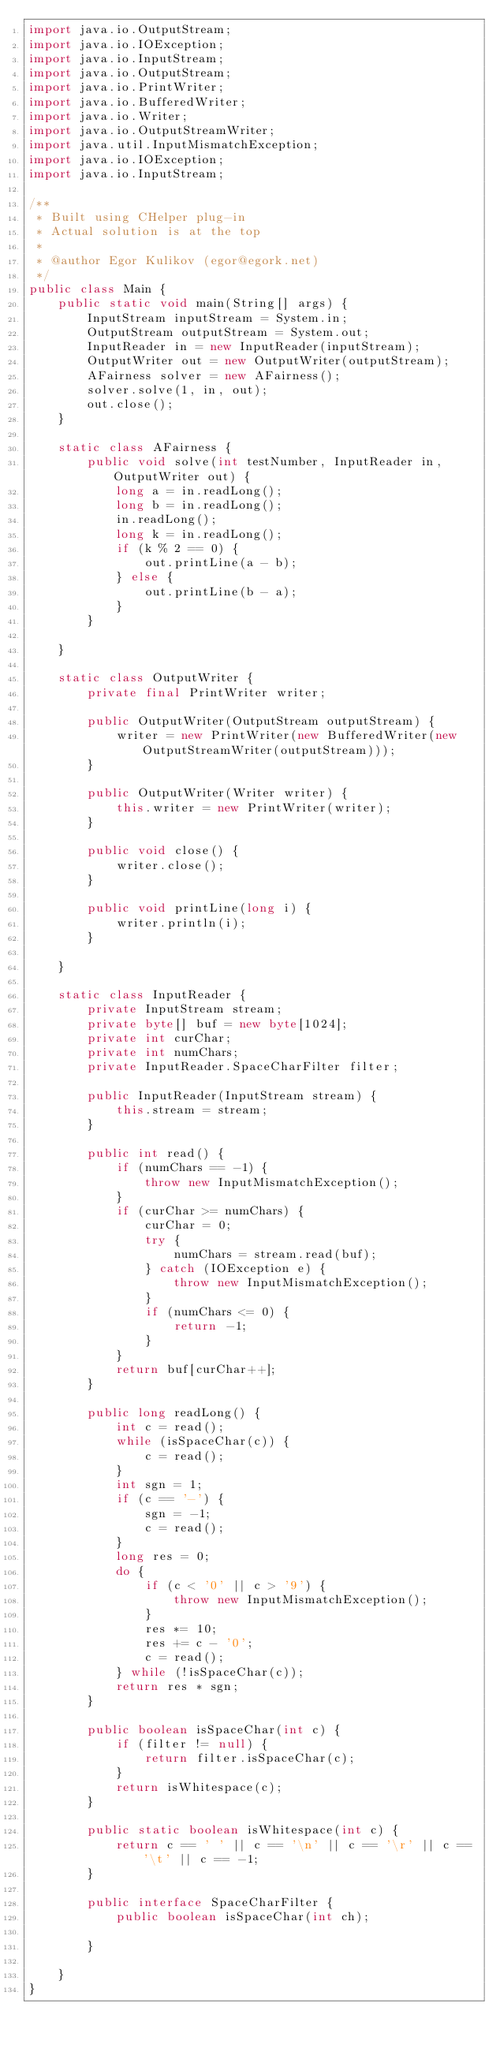Convert code to text. <code><loc_0><loc_0><loc_500><loc_500><_Java_>import java.io.OutputStream;
import java.io.IOException;
import java.io.InputStream;
import java.io.OutputStream;
import java.io.PrintWriter;
import java.io.BufferedWriter;
import java.io.Writer;
import java.io.OutputStreamWriter;
import java.util.InputMismatchException;
import java.io.IOException;
import java.io.InputStream;

/**
 * Built using CHelper plug-in
 * Actual solution is at the top
 *
 * @author Egor Kulikov (egor@egork.net)
 */
public class Main {
    public static void main(String[] args) {
        InputStream inputStream = System.in;
        OutputStream outputStream = System.out;
        InputReader in = new InputReader(inputStream);
        OutputWriter out = new OutputWriter(outputStream);
        AFairness solver = new AFairness();
        solver.solve(1, in, out);
        out.close();
    }

    static class AFairness {
        public void solve(int testNumber, InputReader in, OutputWriter out) {
            long a = in.readLong();
            long b = in.readLong();
            in.readLong();
            long k = in.readLong();
            if (k % 2 == 0) {
                out.printLine(a - b);
            } else {
                out.printLine(b - a);
            }
        }

    }

    static class OutputWriter {
        private final PrintWriter writer;

        public OutputWriter(OutputStream outputStream) {
            writer = new PrintWriter(new BufferedWriter(new OutputStreamWriter(outputStream)));
        }

        public OutputWriter(Writer writer) {
            this.writer = new PrintWriter(writer);
        }

        public void close() {
            writer.close();
        }

        public void printLine(long i) {
            writer.println(i);
        }

    }

    static class InputReader {
        private InputStream stream;
        private byte[] buf = new byte[1024];
        private int curChar;
        private int numChars;
        private InputReader.SpaceCharFilter filter;

        public InputReader(InputStream stream) {
            this.stream = stream;
        }

        public int read() {
            if (numChars == -1) {
                throw new InputMismatchException();
            }
            if (curChar >= numChars) {
                curChar = 0;
                try {
                    numChars = stream.read(buf);
                } catch (IOException e) {
                    throw new InputMismatchException();
                }
                if (numChars <= 0) {
                    return -1;
                }
            }
            return buf[curChar++];
        }

        public long readLong() {
            int c = read();
            while (isSpaceChar(c)) {
                c = read();
            }
            int sgn = 1;
            if (c == '-') {
                sgn = -1;
                c = read();
            }
            long res = 0;
            do {
                if (c < '0' || c > '9') {
                    throw new InputMismatchException();
                }
                res *= 10;
                res += c - '0';
                c = read();
            } while (!isSpaceChar(c));
            return res * sgn;
        }

        public boolean isSpaceChar(int c) {
            if (filter != null) {
                return filter.isSpaceChar(c);
            }
            return isWhitespace(c);
        }

        public static boolean isWhitespace(int c) {
            return c == ' ' || c == '\n' || c == '\r' || c == '\t' || c == -1;
        }

        public interface SpaceCharFilter {
            public boolean isSpaceChar(int ch);

        }

    }
}

</code> 